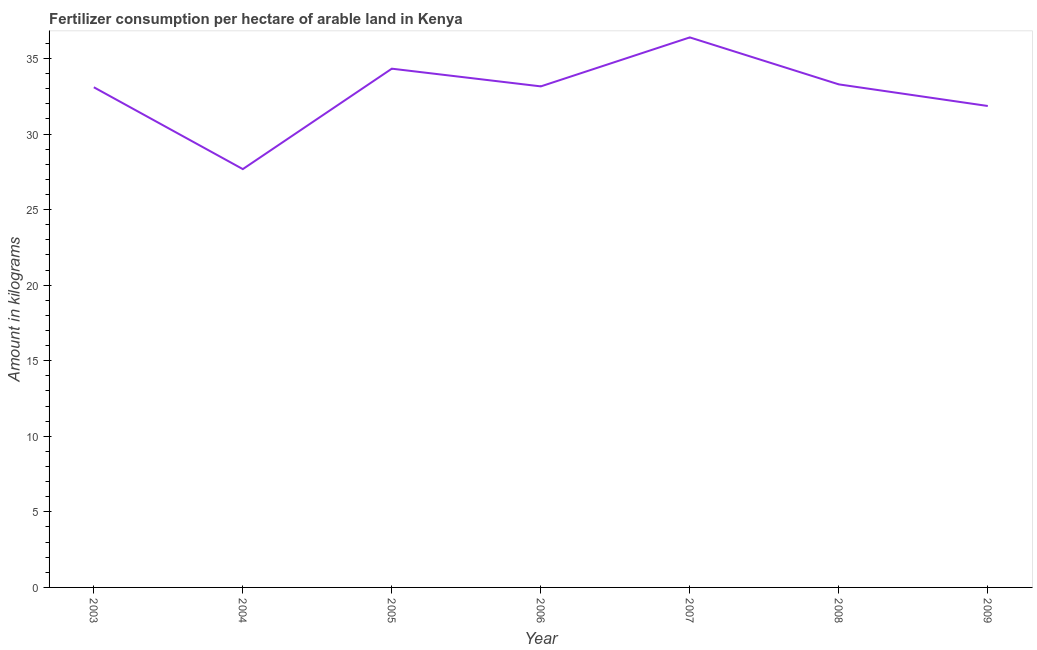What is the amount of fertilizer consumption in 2003?
Ensure brevity in your answer.  33.1. Across all years, what is the maximum amount of fertilizer consumption?
Offer a terse response. 36.4. Across all years, what is the minimum amount of fertilizer consumption?
Keep it short and to the point. 27.68. What is the sum of the amount of fertilizer consumption?
Offer a terse response. 229.8. What is the difference between the amount of fertilizer consumption in 2003 and 2009?
Ensure brevity in your answer.  1.24. What is the average amount of fertilizer consumption per year?
Your answer should be compact. 32.83. What is the median amount of fertilizer consumption?
Offer a very short reply. 33.15. In how many years, is the amount of fertilizer consumption greater than 17 kg?
Offer a terse response. 7. What is the ratio of the amount of fertilizer consumption in 2005 to that in 2009?
Keep it short and to the point. 1.08. Is the difference between the amount of fertilizer consumption in 2003 and 2009 greater than the difference between any two years?
Your answer should be compact. No. What is the difference between the highest and the second highest amount of fertilizer consumption?
Offer a terse response. 2.07. Is the sum of the amount of fertilizer consumption in 2006 and 2009 greater than the maximum amount of fertilizer consumption across all years?
Give a very brief answer. Yes. What is the difference between the highest and the lowest amount of fertilizer consumption?
Provide a succinct answer. 8.71. In how many years, is the amount of fertilizer consumption greater than the average amount of fertilizer consumption taken over all years?
Make the answer very short. 5. How many lines are there?
Give a very brief answer. 1. What is the difference between two consecutive major ticks on the Y-axis?
Ensure brevity in your answer.  5. Does the graph contain any zero values?
Your answer should be very brief. No. Does the graph contain grids?
Your answer should be very brief. No. What is the title of the graph?
Keep it short and to the point. Fertilizer consumption per hectare of arable land in Kenya . What is the label or title of the Y-axis?
Your response must be concise. Amount in kilograms. What is the Amount in kilograms in 2003?
Ensure brevity in your answer.  33.1. What is the Amount in kilograms of 2004?
Offer a very short reply. 27.68. What is the Amount in kilograms of 2005?
Provide a succinct answer. 34.33. What is the Amount in kilograms in 2006?
Your response must be concise. 33.15. What is the Amount in kilograms of 2007?
Provide a short and direct response. 36.4. What is the Amount in kilograms of 2008?
Offer a terse response. 33.29. What is the Amount in kilograms in 2009?
Provide a succinct answer. 31.86. What is the difference between the Amount in kilograms in 2003 and 2004?
Give a very brief answer. 5.42. What is the difference between the Amount in kilograms in 2003 and 2005?
Your response must be concise. -1.23. What is the difference between the Amount in kilograms in 2003 and 2006?
Provide a short and direct response. -0.06. What is the difference between the Amount in kilograms in 2003 and 2007?
Offer a very short reply. -3.3. What is the difference between the Amount in kilograms in 2003 and 2008?
Give a very brief answer. -0.19. What is the difference between the Amount in kilograms in 2003 and 2009?
Make the answer very short. 1.24. What is the difference between the Amount in kilograms in 2004 and 2005?
Make the answer very short. -6.65. What is the difference between the Amount in kilograms in 2004 and 2006?
Keep it short and to the point. -5.47. What is the difference between the Amount in kilograms in 2004 and 2007?
Keep it short and to the point. -8.71. What is the difference between the Amount in kilograms in 2004 and 2008?
Your answer should be compact. -5.61. What is the difference between the Amount in kilograms in 2004 and 2009?
Your answer should be very brief. -4.18. What is the difference between the Amount in kilograms in 2005 and 2006?
Give a very brief answer. 1.17. What is the difference between the Amount in kilograms in 2005 and 2007?
Ensure brevity in your answer.  -2.07. What is the difference between the Amount in kilograms in 2005 and 2008?
Provide a short and direct response. 1.04. What is the difference between the Amount in kilograms in 2005 and 2009?
Your answer should be compact. 2.47. What is the difference between the Amount in kilograms in 2006 and 2007?
Offer a terse response. -3.24. What is the difference between the Amount in kilograms in 2006 and 2008?
Keep it short and to the point. -0.13. What is the difference between the Amount in kilograms in 2006 and 2009?
Your answer should be very brief. 1.3. What is the difference between the Amount in kilograms in 2007 and 2008?
Keep it short and to the point. 3.11. What is the difference between the Amount in kilograms in 2007 and 2009?
Make the answer very short. 4.54. What is the difference between the Amount in kilograms in 2008 and 2009?
Your response must be concise. 1.43. What is the ratio of the Amount in kilograms in 2003 to that in 2004?
Offer a terse response. 1.2. What is the ratio of the Amount in kilograms in 2003 to that in 2007?
Offer a terse response. 0.91. What is the ratio of the Amount in kilograms in 2003 to that in 2009?
Offer a terse response. 1.04. What is the ratio of the Amount in kilograms in 2004 to that in 2005?
Make the answer very short. 0.81. What is the ratio of the Amount in kilograms in 2004 to that in 2006?
Provide a short and direct response. 0.83. What is the ratio of the Amount in kilograms in 2004 to that in 2007?
Keep it short and to the point. 0.76. What is the ratio of the Amount in kilograms in 2004 to that in 2008?
Provide a short and direct response. 0.83. What is the ratio of the Amount in kilograms in 2004 to that in 2009?
Keep it short and to the point. 0.87. What is the ratio of the Amount in kilograms in 2005 to that in 2006?
Make the answer very short. 1.03. What is the ratio of the Amount in kilograms in 2005 to that in 2007?
Make the answer very short. 0.94. What is the ratio of the Amount in kilograms in 2005 to that in 2008?
Provide a short and direct response. 1.03. What is the ratio of the Amount in kilograms in 2005 to that in 2009?
Your response must be concise. 1.08. What is the ratio of the Amount in kilograms in 2006 to that in 2007?
Your answer should be compact. 0.91. What is the ratio of the Amount in kilograms in 2006 to that in 2009?
Ensure brevity in your answer.  1.04. What is the ratio of the Amount in kilograms in 2007 to that in 2008?
Your answer should be very brief. 1.09. What is the ratio of the Amount in kilograms in 2007 to that in 2009?
Ensure brevity in your answer.  1.14. What is the ratio of the Amount in kilograms in 2008 to that in 2009?
Your response must be concise. 1.04. 